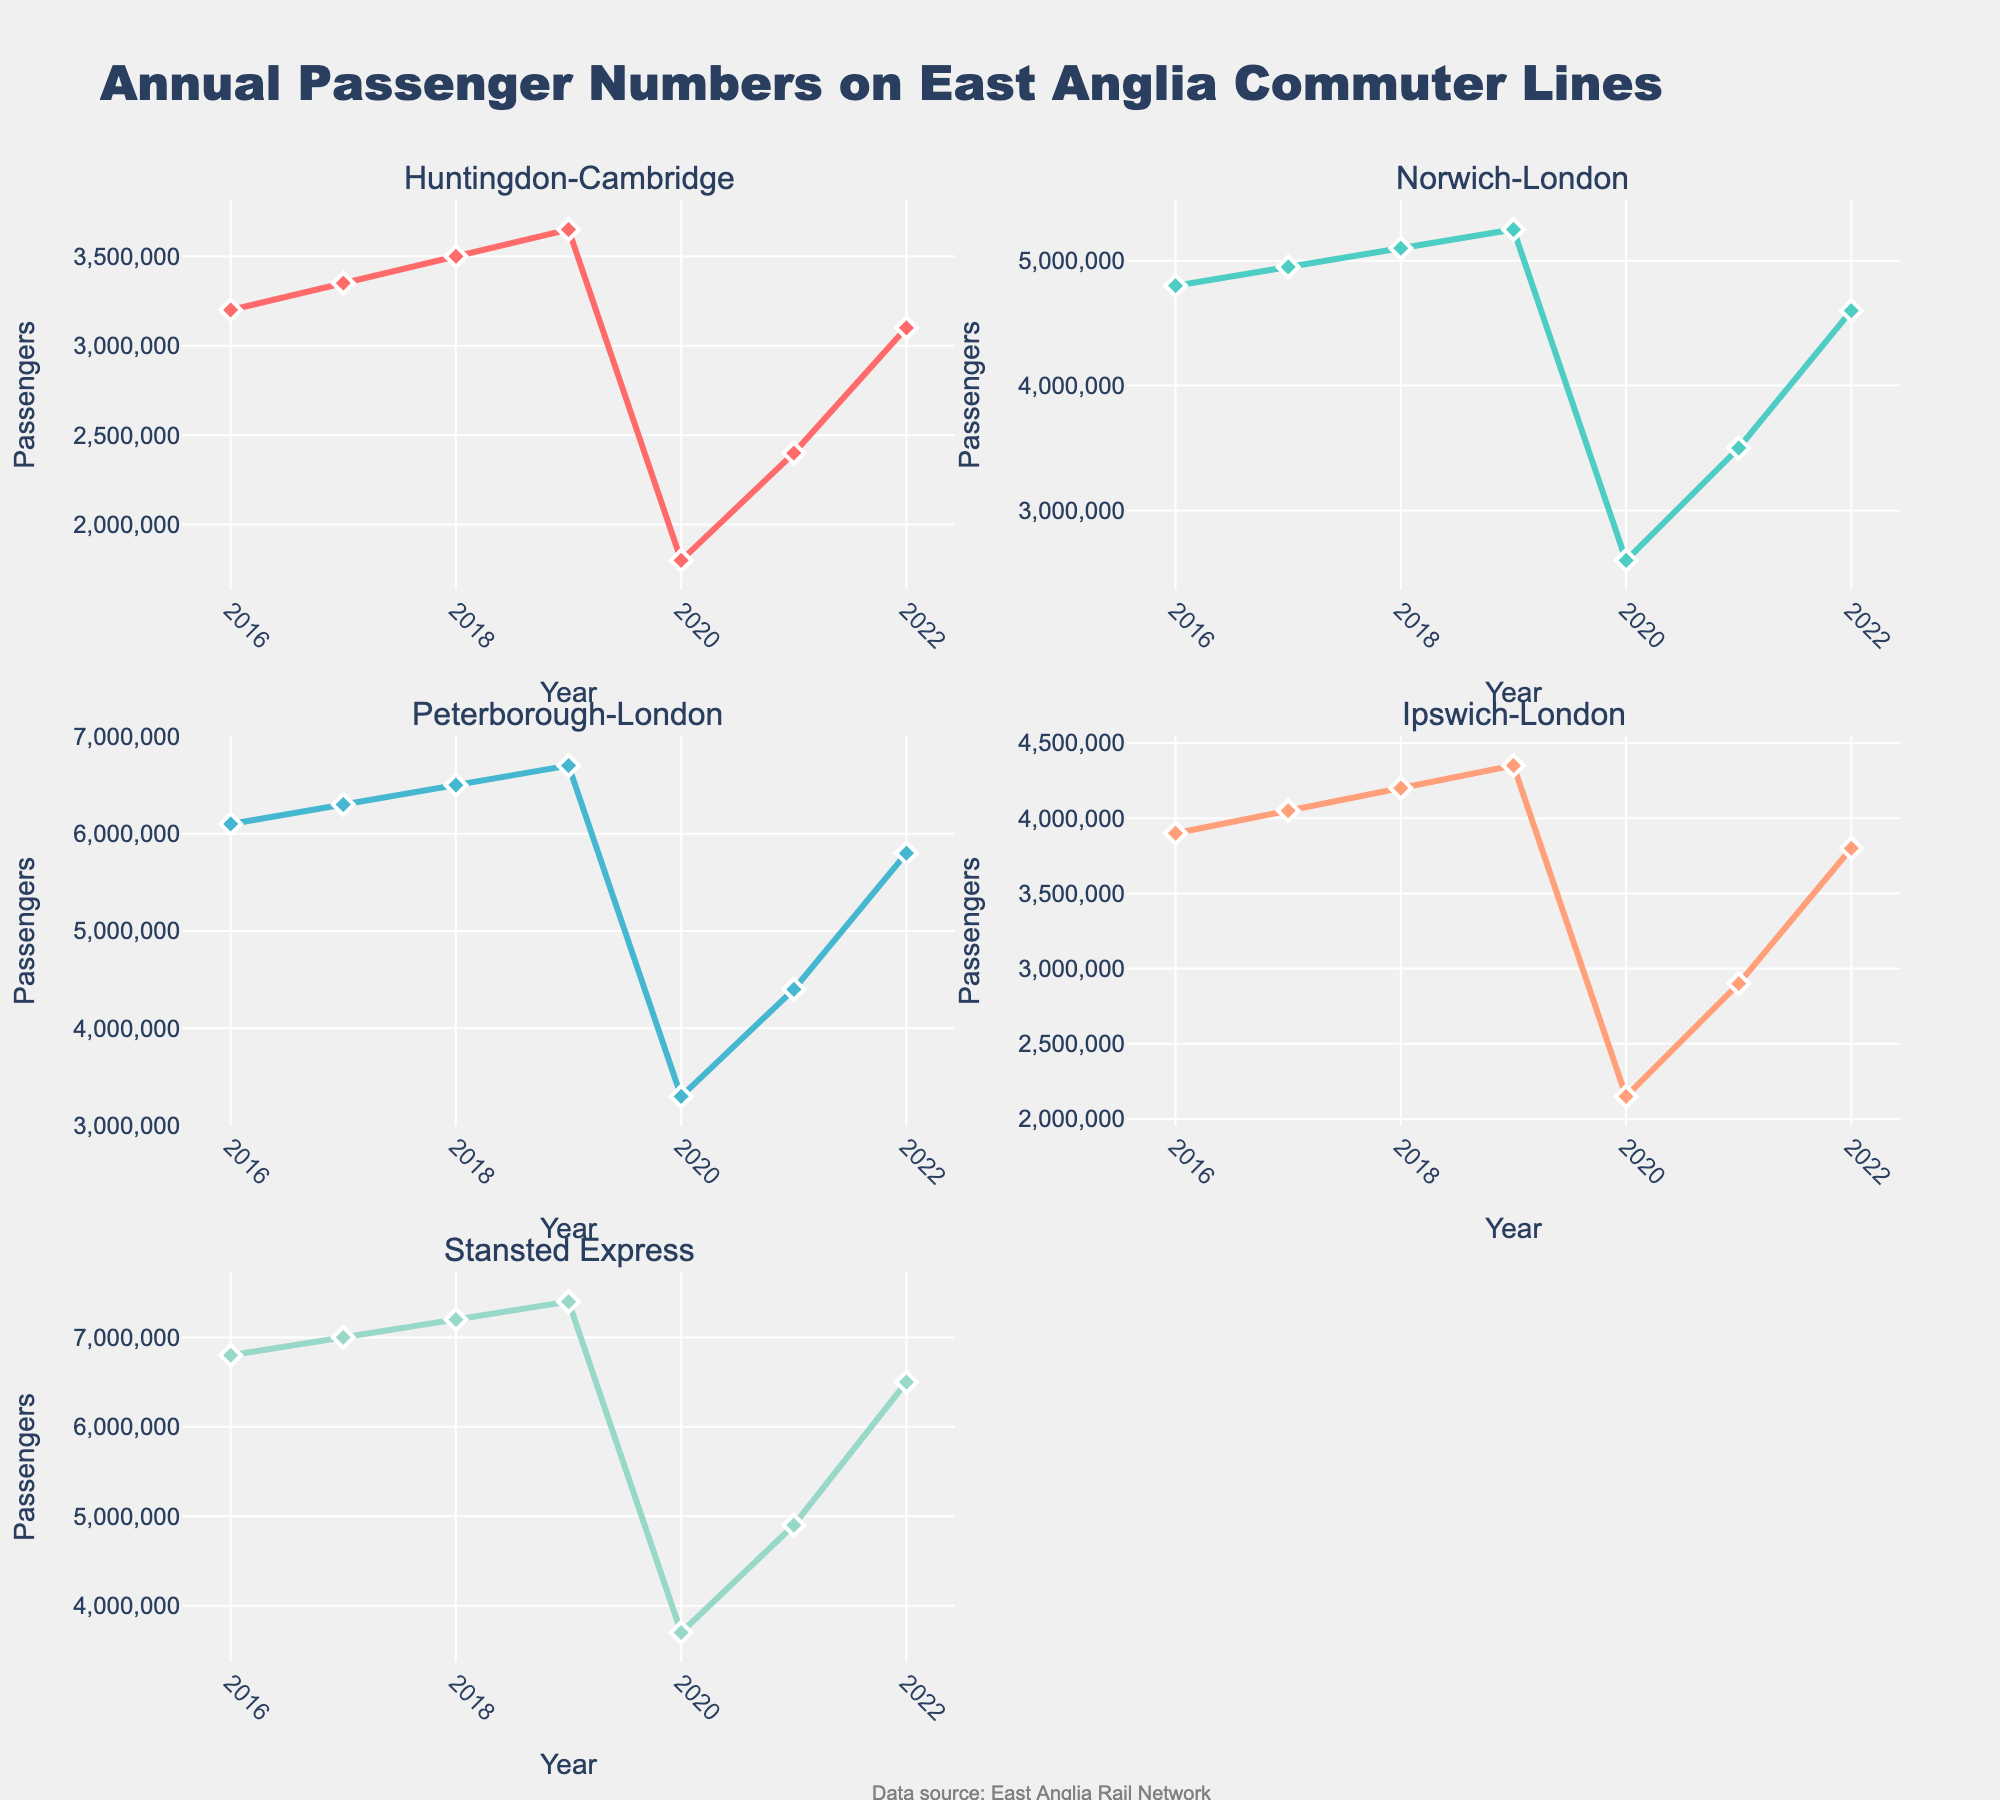What's the title of the figure? The title of the figure is displayed at the top of the overall chart. It reads "Annual Passenger Numbers on East Anglia Commuter Lines".
Answer: Annual Passenger Numbers on East Anglia Commuter Lines How many rows and columns of plots are there in the figure? The figure is arranged in a grid of subplots. By counting the rows and columns, there are 3 rows and 2 columns.
Answer: 3 rows and 2 columns Which route had the highest number of passengers in 2019? Looking at the data points on the subplots for 2019, the Stansted Express line shows the highest number of passengers, as it reaches the highest point compared to other lines.
Answer: Stansted Express Which route showed the most significant drop in passengers from 2019 to 2020? By comparing the vertical distance between the 2019 and 2020 data points in each subplot, the Stansted Express shows the steepest drop among all lines.
Answer: Stansted Express What's the primary trend observed for the Huntingdon-Cambridge route from 2016 to 2022? The line representing the Huntingdon-Cambridge route shows a general upwards trend from 2016 to 2019, a significant drop in 2020, followed by a steady recovery from 2021 to 2022.
Answer: Upwards trend, drop in 2020, followed by recovery What is the difference in passenger numbers for the Ipswich-London route between 2021 and 2022? On the Ipswich-London subplot, the data points for 2021 and 2022 show 2,900,000 and 3,800,000 passengers respectively. The difference is 3,800,000 - 2,900,000.
Answer: 900,000 Which two routes had passenger numbers that recovered to pre-2020 levels by 2022? By examining the subplots, the Norwich-London and Peterborough-London routes show passenger numbers in 2022 that are equal to or greater than the numbers in 2019.
Answer: Norwich-London and Peterborough-London How did the number of passengers on the Peterborough-London route change from 2020 to 2021? In the Peterborough-London subplot, the number of passengers increased from 3,300,000 in 2020 to 4,400,000 in 2021. The change is 4,400,000 - 3,300,000.
Answer: Increased by 1,100,000 Describe the overall pattern of passenger numbers for each route during 2020. Each subplot shows a sharp decline in passenger numbers during 2020, which is consistent across all routes.
Answer: Sharp decline Which year did the Huntingdon-Cambridge route first cross 3,000,000 passengers? Observing the Huntingdon-Cambridge subplot, the data point in 2017 first crosses the 3,000,000 mark.
Answer: 2017 